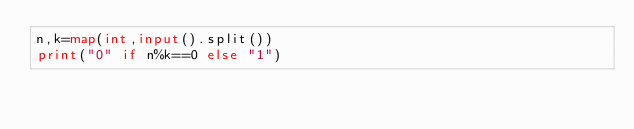Convert code to text. <code><loc_0><loc_0><loc_500><loc_500><_Python_>n,k=map(int,input().split())
print("0" if n%k==0 else "1")</code> 